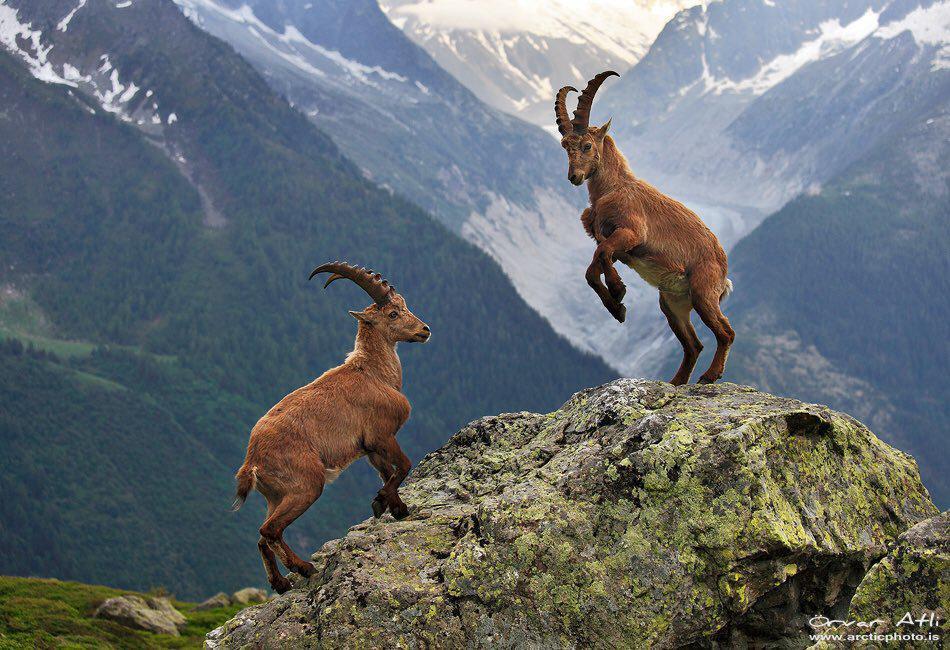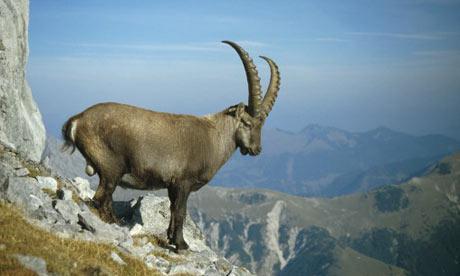The first image is the image on the left, the second image is the image on the right. Assess this claim about the two images: "Three horned animals are in a grassy area in the image on the right.". Correct or not? Answer yes or no. No. The first image is the image on the left, the second image is the image on the right. Evaluate the accuracy of this statement regarding the images: "An image includes a rearing horned animal with front legs raised, facing off with another horned animal.". Is it true? Answer yes or no. Yes. 